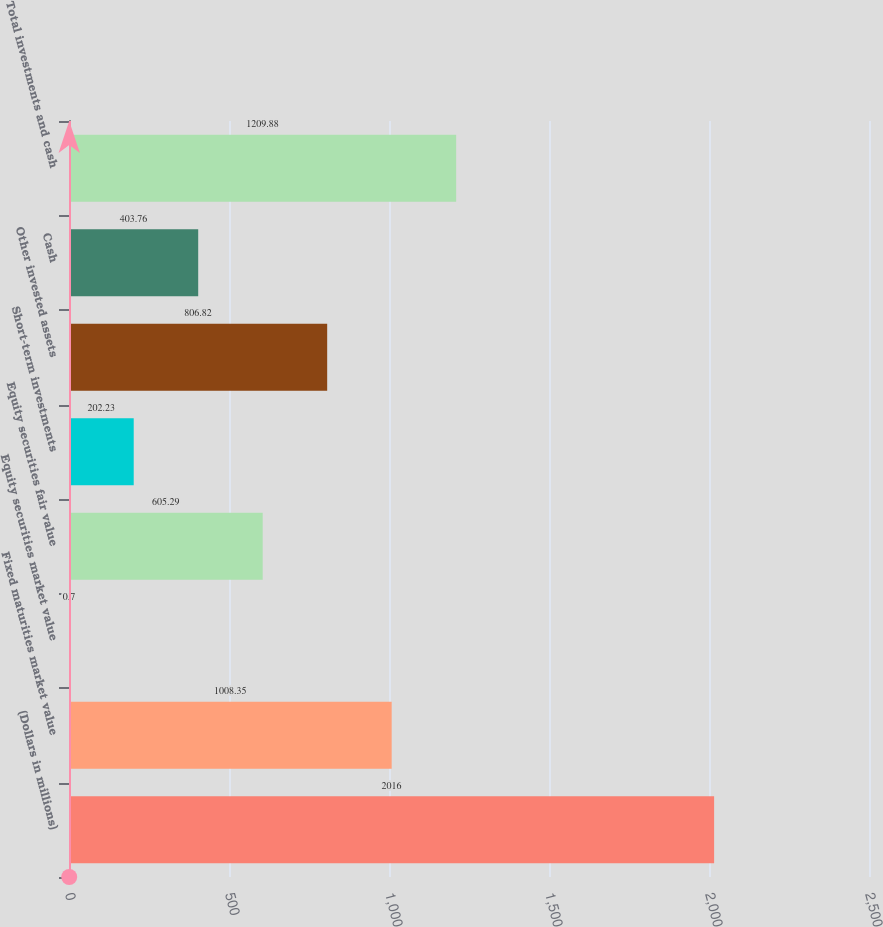Convert chart to OTSL. <chart><loc_0><loc_0><loc_500><loc_500><bar_chart><fcel>(Dollars in millions)<fcel>Fixed maturities market value<fcel>Equity securities market value<fcel>Equity securities fair value<fcel>Short-term investments<fcel>Other invested assets<fcel>Cash<fcel>Total investments and cash<nl><fcel>2016<fcel>1008.35<fcel>0.7<fcel>605.29<fcel>202.23<fcel>806.82<fcel>403.76<fcel>1209.88<nl></chart> 